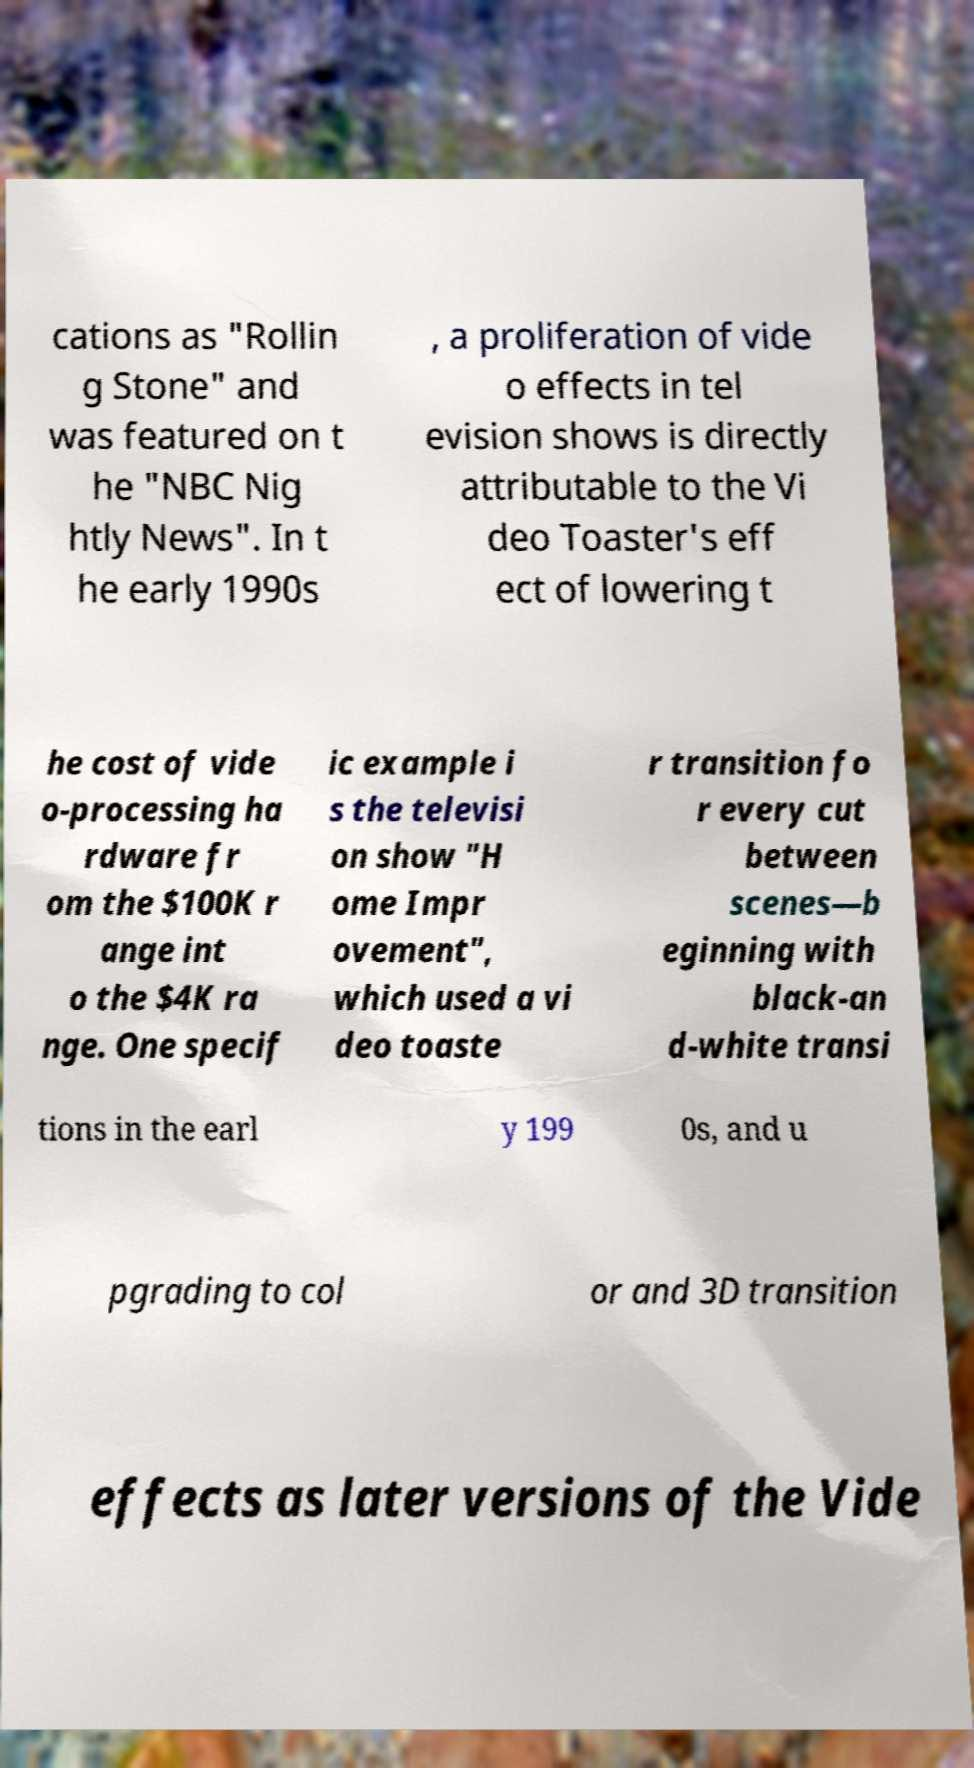Please read and relay the text visible in this image. What does it say? cations as "Rollin g Stone" and was featured on t he "NBC Nig htly News". In t he early 1990s , a proliferation of vide o effects in tel evision shows is directly attributable to the Vi deo Toaster's eff ect of lowering t he cost of vide o-processing ha rdware fr om the $100K r ange int o the $4K ra nge. One specif ic example i s the televisi on show "H ome Impr ovement", which used a vi deo toaste r transition fo r every cut between scenes—b eginning with black-an d-white transi tions in the earl y 199 0s, and u pgrading to col or and 3D transition effects as later versions of the Vide 